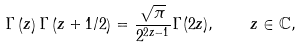<formula> <loc_0><loc_0><loc_500><loc_500>\Gamma \left ( z \right ) \Gamma \left ( z + 1 / 2 \right ) = \frac { \sqrt { \pi } } { 2 ^ { 2 z - 1 } } \Gamma ( 2 z ) , \quad z \in \mathbb { C } ,</formula> 